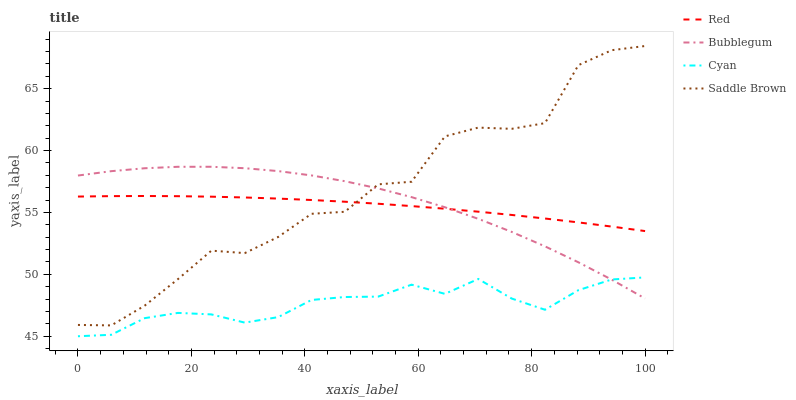Does Cyan have the minimum area under the curve?
Answer yes or no. Yes. Does Saddle Brown have the maximum area under the curve?
Answer yes or no. Yes. Does Bubblegum have the minimum area under the curve?
Answer yes or no. No. Does Bubblegum have the maximum area under the curve?
Answer yes or no. No. Is Red the smoothest?
Answer yes or no. Yes. Is Saddle Brown the roughest?
Answer yes or no. Yes. Is Bubblegum the smoothest?
Answer yes or no. No. Is Bubblegum the roughest?
Answer yes or no. No. Does Cyan have the lowest value?
Answer yes or no. Yes. Does Bubblegum have the lowest value?
Answer yes or no. No. Does Saddle Brown have the highest value?
Answer yes or no. Yes. Does Bubblegum have the highest value?
Answer yes or no. No. Is Cyan less than Saddle Brown?
Answer yes or no. Yes. Is Red greater than Cyan?
Answer yes or no. Yes. Does Cyan intersect Bubblegum?
Answer yes or no. Yes. Is Cyan less than Bubblegum?
Answer yes or no. No. Is Cyan greater than Bubblegum?
Answer yes or no. No. Does Cyan intersect Saddle Brown?
Answer yes or no. No. 